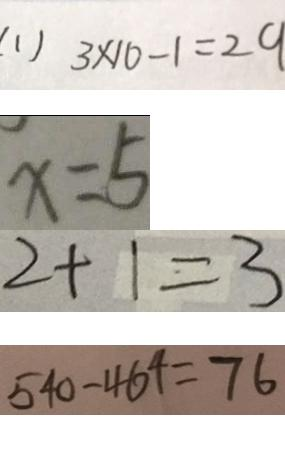Convert formula to latex. <formula><loc_0><loc_0><loc_500><loc_500>( 1 ) 3 \times 1 0 - 1 = 2 9 
 x = 5 
 2 + 1 = 3 
 5 4 0 - 4 6 4 = 7 6</formula> 